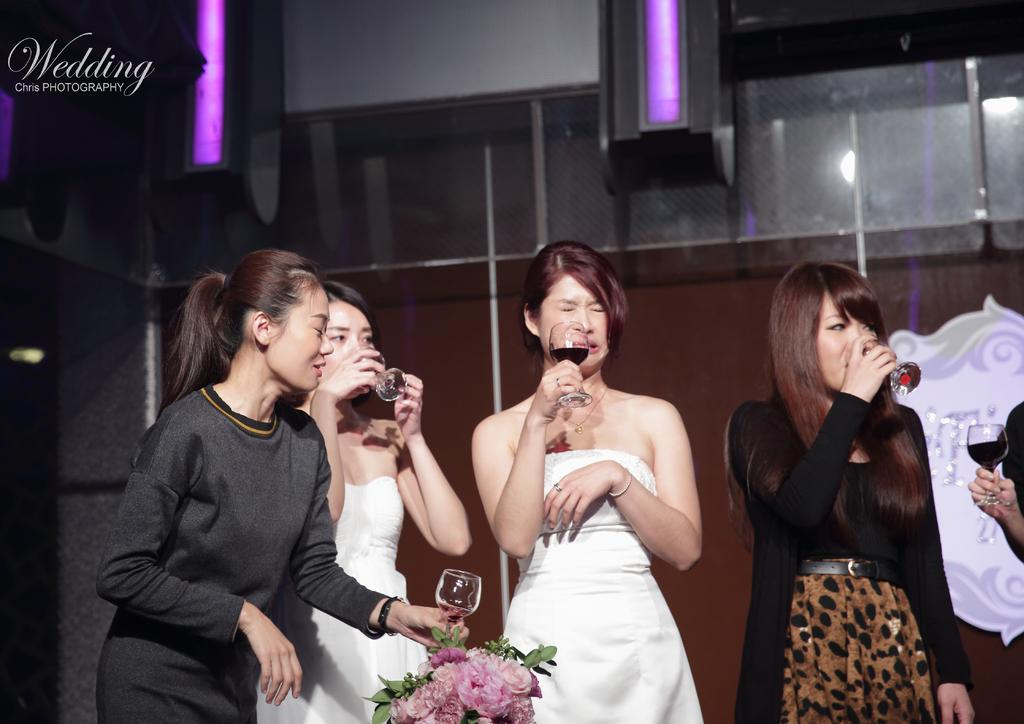What are the women in the image holding? The women are holding glasses in the image. What type of vegetation can be seen in the image? There are flowers and leaves in the image. What can be seen in the background of the image? There is a wall, mesh, a hoarding, and other objects visible in the background of the image. What type of insurance policy is advertised on the hoarding in the image? There is no insurance policy advertised on the hoarding in the image; it is not mentioned in the provided facts. What kind of apparatus is being used by the women to hold the glasses? There is no apparatus mentioned in the image; the women are simply holding the glasses with their hands. 